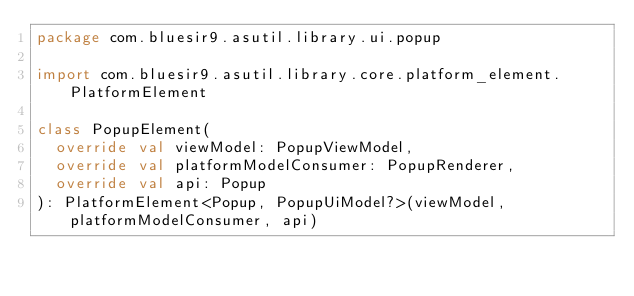Convert code to text. <code><loc_0><loc_0><loc_500><loc_500><_Kotlin_>package com.bluesir9.asutil.library.ui.popup

import com.bluesir9.asutil.library.core.platform_element.PlatformElement

class PopupElement(
  override val viewModel: PopupViewModel,
  override val platformModelConsumer: PopupRenderer,
  override val api: Popup
): PlatformElement<Popup, PopupUiModel?>(viewModel, platformModelConsumer, api)</code> 